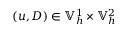<formula> <loc_0><loc_0><loc_500><loc_500>( u , D ) \in \mathbb { V } _ { h } ^ { 1 } \times \mathbb { V } _ { h } ^ { 2 }</formula> 